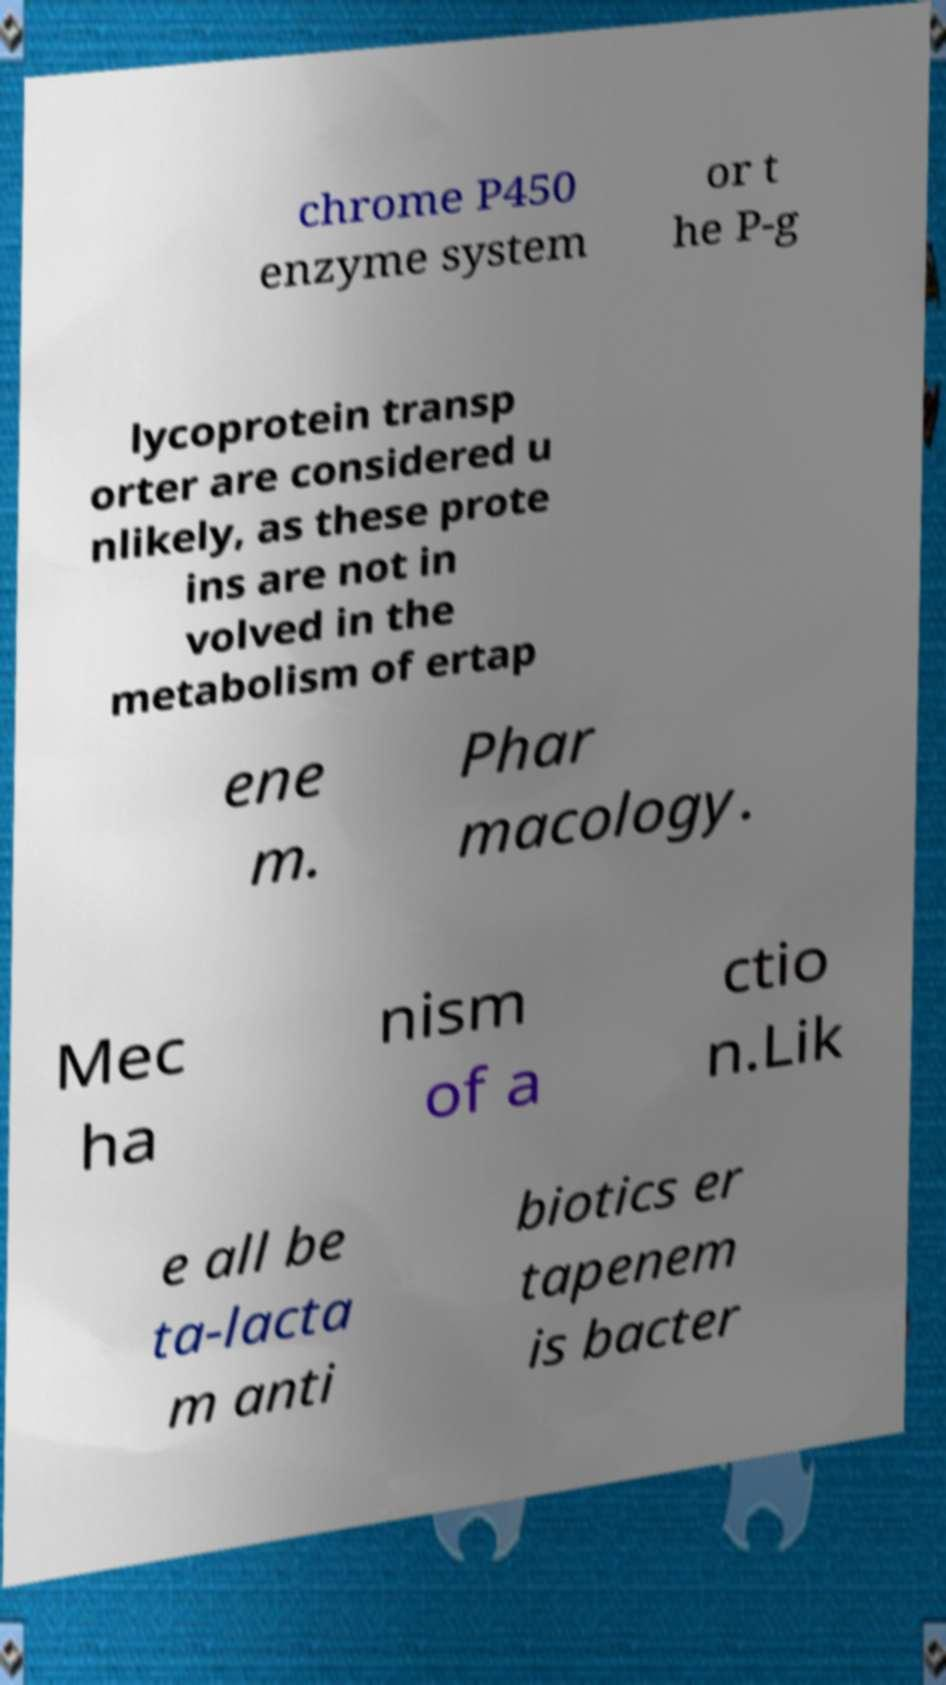What messages or text are displayed in this image? I need them in a readable, typed format. chrome P450 enzyme system or t he P-g lycoprotein transp orter are considered u nlikely, as these prote ins are not in volved in the metabolism of ertap ene m. Phar macology. Mec ha nism of a ctio n.Lik e all be ta-lacta m anti biotics er tapenem is bacter 